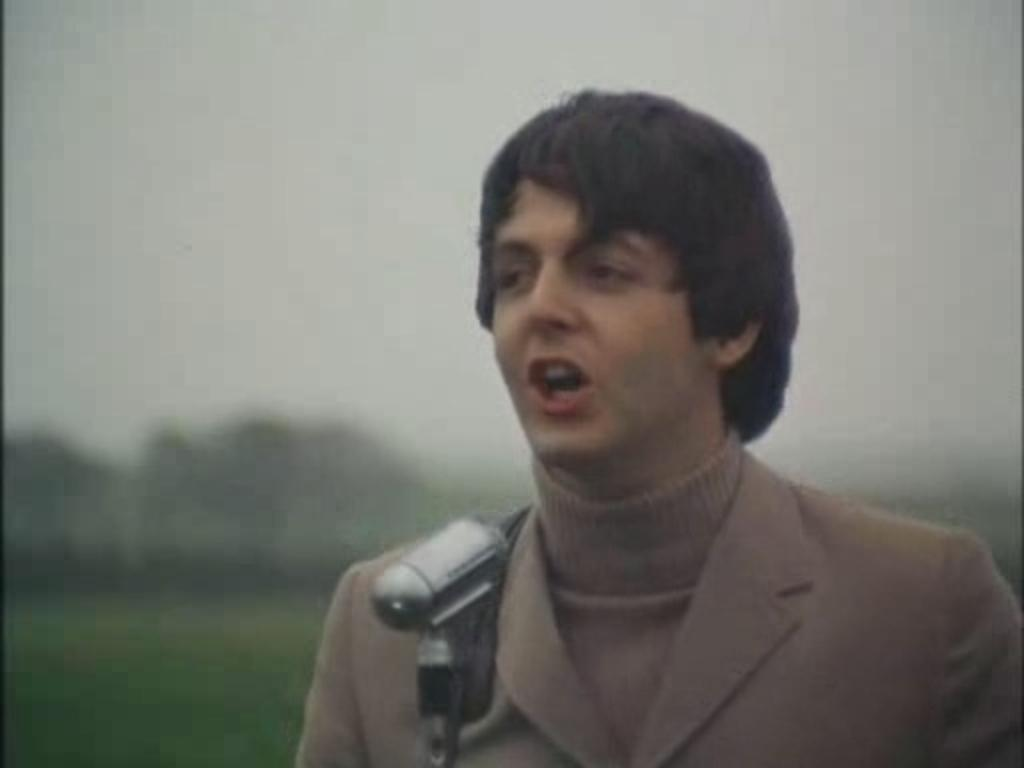Who is the main subject in the image? There is a man in the image. What is the man wearing? The man is wearing a brown jacket. What is the man doing in the image? The man is speaking into a microphone. What type of rain is falling in the image? There is no rain present in the image. What activity is the servant performing in the image? There is no servant present in the image. 